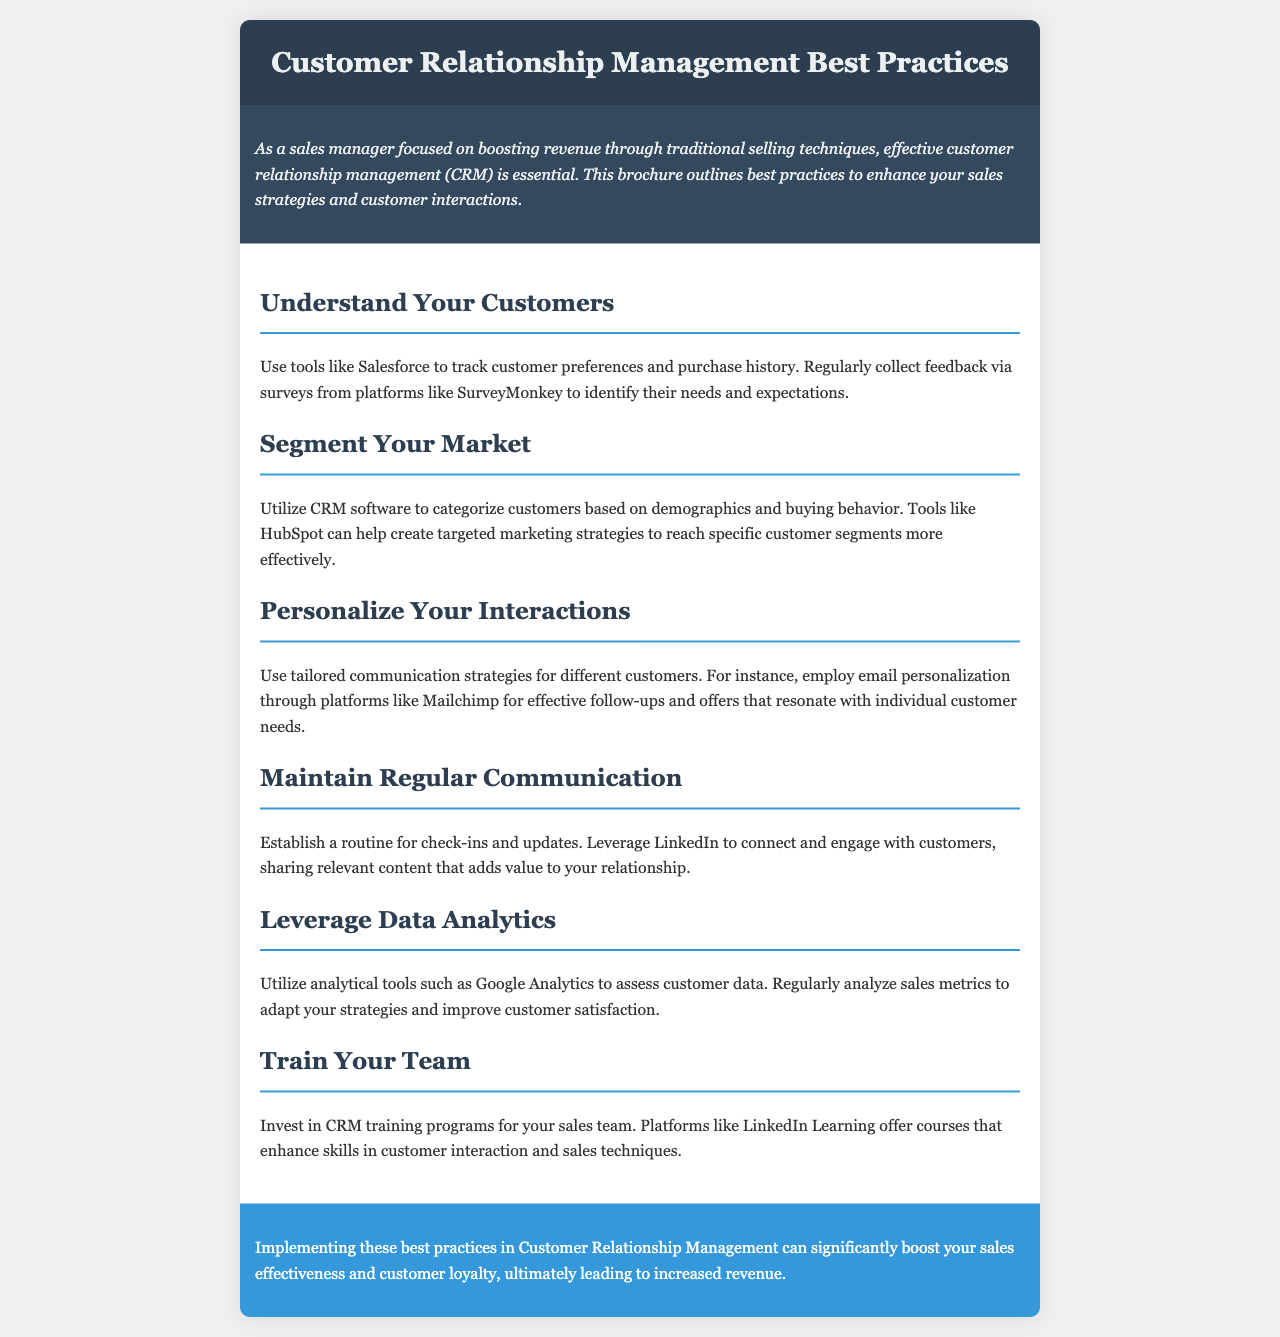What is the title of the brochure? The title is prominently displayed in the header section of the brochure.
Answer: Customer Relationship Management Best Practices What is the main focus of the brochure? The introduction outlines the key purpose of the document, which is aimed at improving customer interactions.
Answer: Effective customer relationship management Which CRM tool is mentioned for tracking customer preferences? The document specifies a tool to help with tracking customer data in a specified section.
Answer: Salesforce What platform is suggested for collecting customer feedback? A specific platform is mentioned for gathering insights from customers.
Answer: SurveyMonkey What analytical tool is recommended for assessing customer data? The document mentions a specific tool used for analyzing sales metrics and customer behavior.
Answer: Google Analytics Which platform is suggested for training the sales team? In the section dedicated to team training, a specific training platform is highlighted.
Answer: LinkedIn Learning What is a key strategy to enhance customer communication? The document suggests a specific approach to tailor communications with customers.
Answer: Personalization How can sales managers enhance market targeting? The brochure provides guidance on segmenting the market using particular software.
Answer: CRM software What is the conclusion about the impact of these best practices? The conclusion summarizes the expected outcome of implementing the recommended practices.
Answer: Increased revenue 